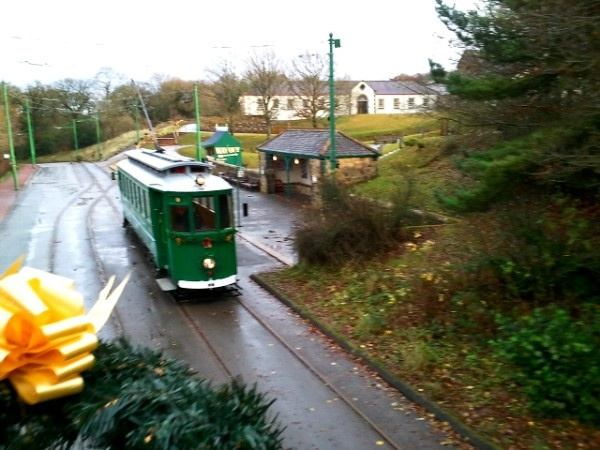Describe the objects in this image and their specific colors. I can see train in white, black, darkgreen, and gray tones, bus in white, black, darkgreen, and darkgray tones, and bench in white, gray, and black tones in this image. 